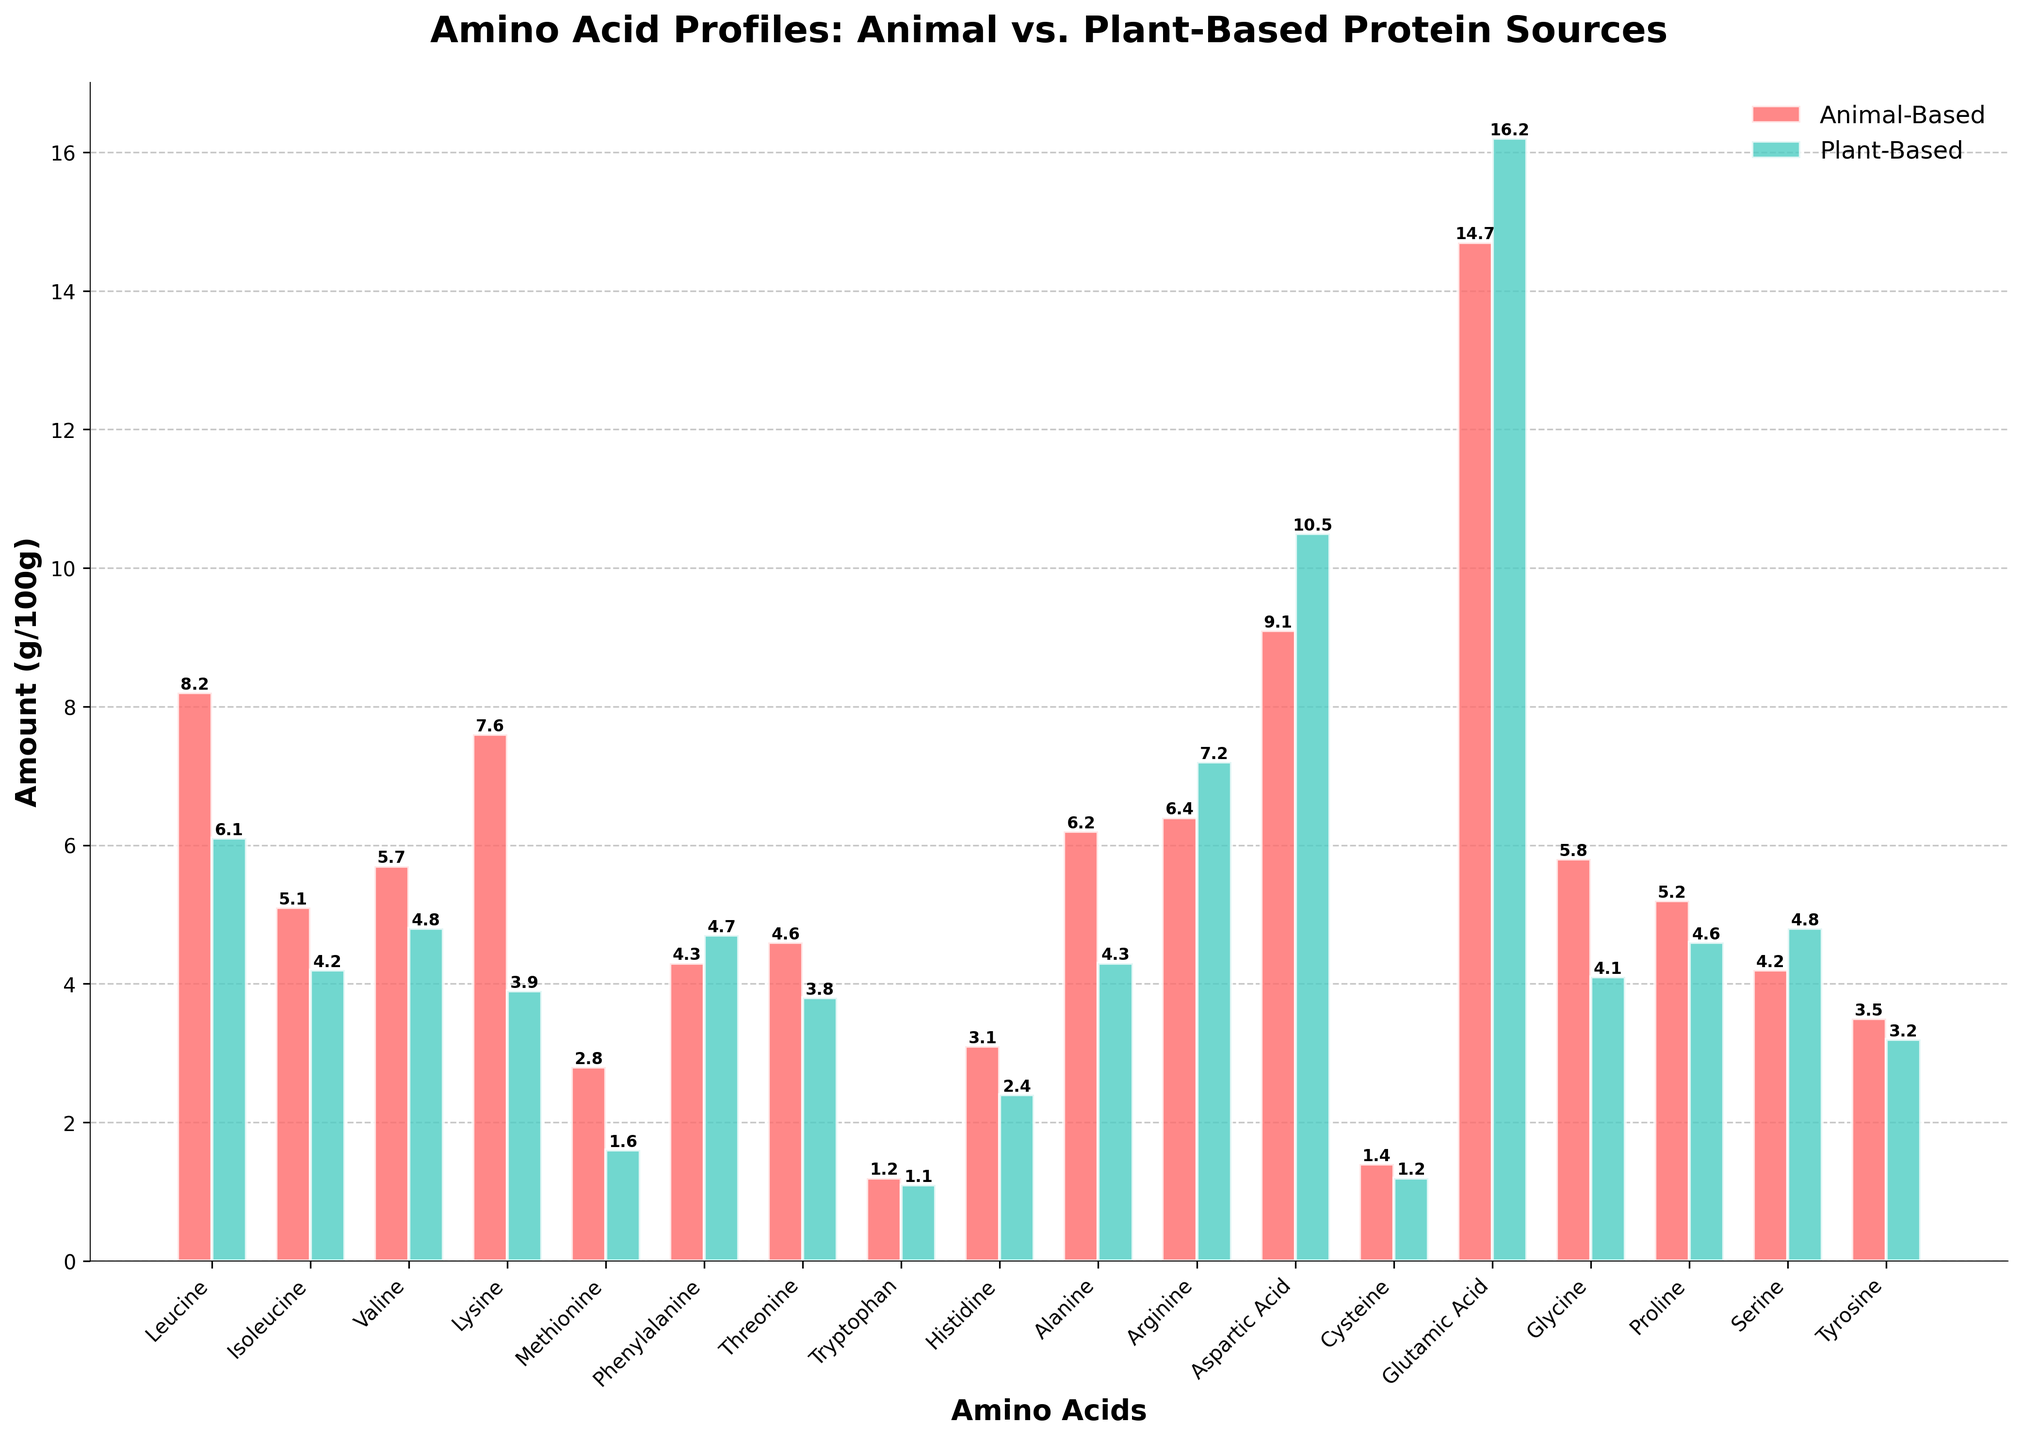Which amino acid has the highest amount in plant-based protein sources? To determine the amino acid with the highest quantity in plant-based protein, look for the tallest green bar in the chart. The tallest green bar corresponds to Glutamic Acid with 16.2 g/100g.
Answer: Glutamic Acid Which has higher amounts of Lysine, animal-based or plant-based protein sources? Compare the heights of the red and green bars corresponding to Lysine. The red bar for animal-based protein is taller than the green bar for plant-based protein, indicating that animal-based Lysine is higher.
Answer: Animal-based What are the three amino acids with the largest differences between animal-based and plant-based protein sources? Calculate the differences for each amino acid by subtracting the plant-based amount from the animal-based amount, and identify the three largest differences. The differences are: Lysine (3.7), Leucine (2.1), and Alanine (1.9).
Answer: Lysine, Leucine, Alanine For animal-based sources, which amino acid has the lowest value, and what is its amount? Look for the shortest red bar in the chart to see the amino acid with the smallest value in animal-based protein sources. The shortest red bar corresponds to Tryptophan, which has 1.2 g/100g.
Answer: Tryptophan, 1.2 g/100g How does Methionine compare between animal-based and plant-based sources? Is it higher, lower, or the same? Compare the heights of the red and green bars for Methionine. The red bar (animal-based) is taller than the green bar (plant-based), meaning animal-based Methionine is higher.
Answer: Higher What is the total sum of Leucine and Valine in plant-based proteins? Sum the amounts of Leucine and Valine for plant-based proteins. Leucine is 6.1 g/100g and Valine is 4.8 g/100g, so their sum is 6.1 + 4.8 = 10.9 g/100g.
Answer: 10.9 g/100g Which amino acid has a higher concentration in plant-based proteins compared to animal-based proteins? Look for green bars that are taller than red bars to determine which amino acid is more concentrated in plant-based proteins. Arginine and Aspartic Acid have higher concentrations in plant-based proteins.
Answer: Arginine, Aspartic Acid Which amino acid shows the least difference between animal-based and plant-based sources? Find the amino acid with bars that have the most similar height by looking at the chart closely. The Methionine and Cysteine bars are similar, both differing by 0.2 or less with Cysteine having a difference of 0.2 g/100g.
Answer: Cysteine What pattern can you observe between Aspartic Acid and Glutamic Acid in both types of protein sources? Observe the heights of the Aspartic Acid and Glutamic Acid bars for both protein sources. Both amino acids are among the highest in both animal-based and plant-based sources, with Glutamic Acid being higher in plant-based and animal-based protein having lower for Aspartic Acid comparatively.
Answer: High in both, higher in plant-based Which amino acid has almost equal amounts in both animal-based and plant-based sources? Look for bars where the red and green heights are nearly the same. Phenylalanine has similar amounts in both sources, with plant-based being slightly higher by 0.4 g/100g.
Answer: Phenylalanine 